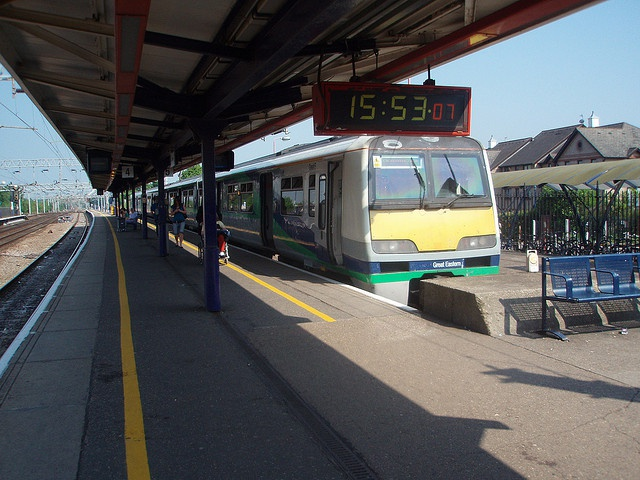Describe the objects in this image and their specific colors. I can see train in black, gray, darkgray, and khaki tones, clock in black, maroon, darkgreen, and gray tones, bench in black, blue, navy, and gray tones, chair in black, blue, gray, and navy tones, and people in black, maroon, navy, and blue tones in this image. 